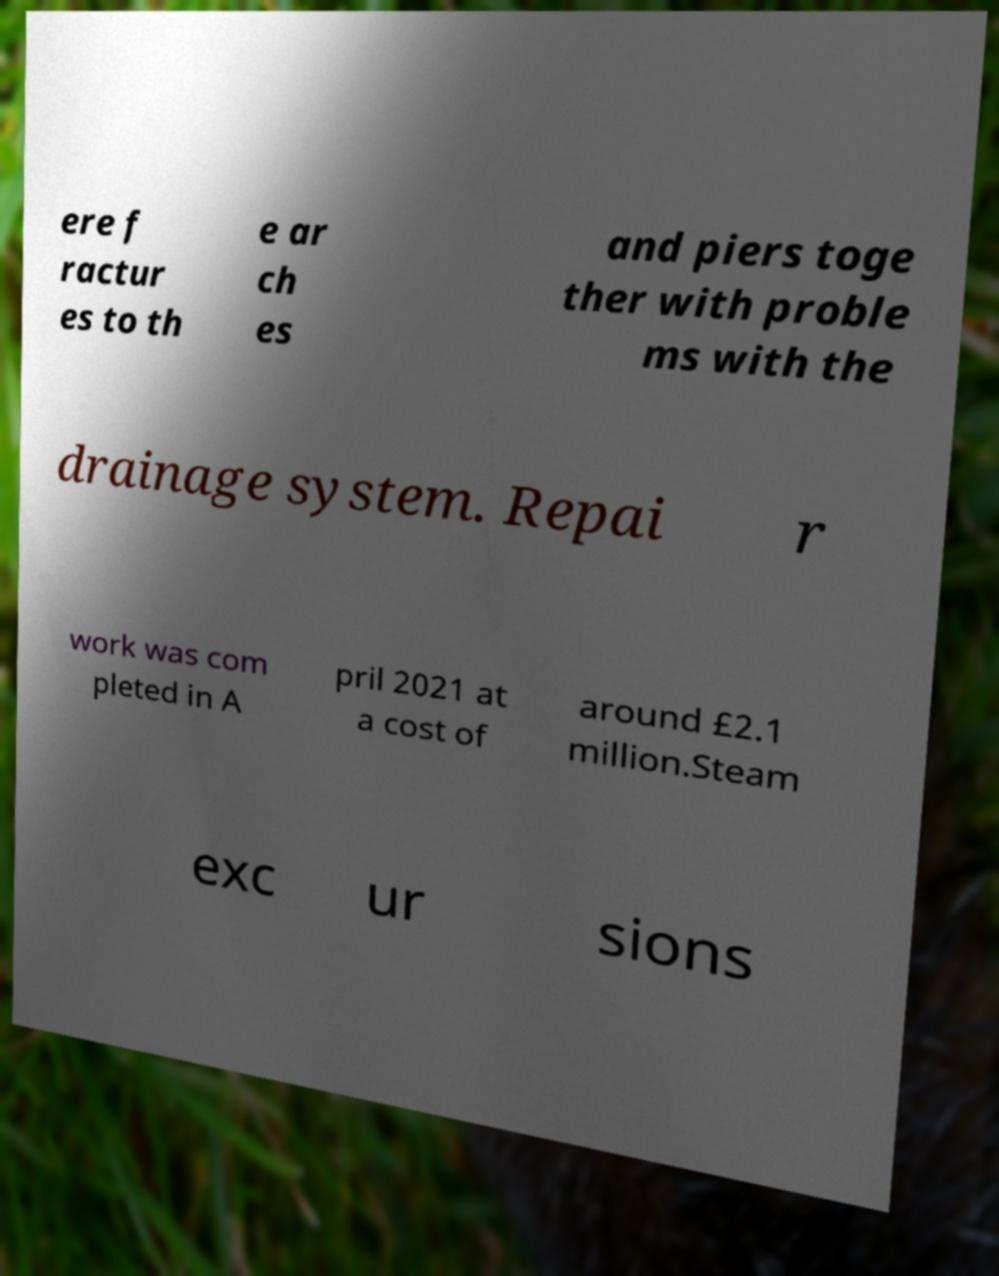Can you read and provide the text displayed in the image?This photo seems to have some interesting text. Can you extract and type it out for me? ere f ractur es to th e ar ch es and piers toge ther with proble ms with the drainage system. Repai r work was com pleted in A pril 2021 at a cost of around £2.1 million.Steam exc ur sions 